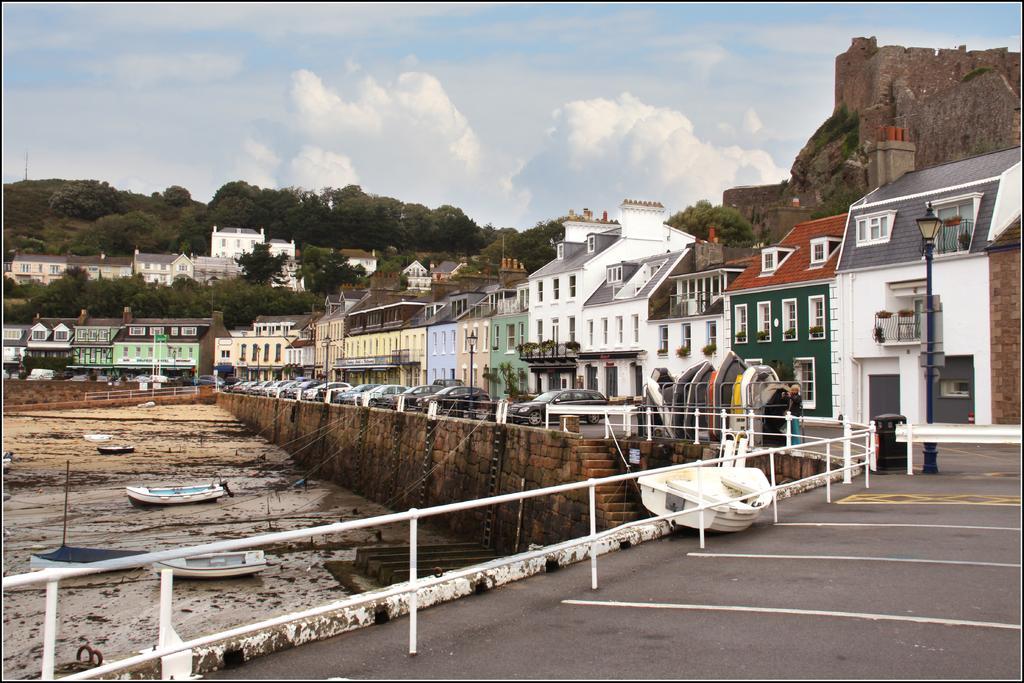Describe this image in one or two sentences. In this picture we can see few boats, cars, metal rods, buildings and trees, in the right side of the given image we can see a person is standing near to the boat, in the background we can find hills and clouds. 